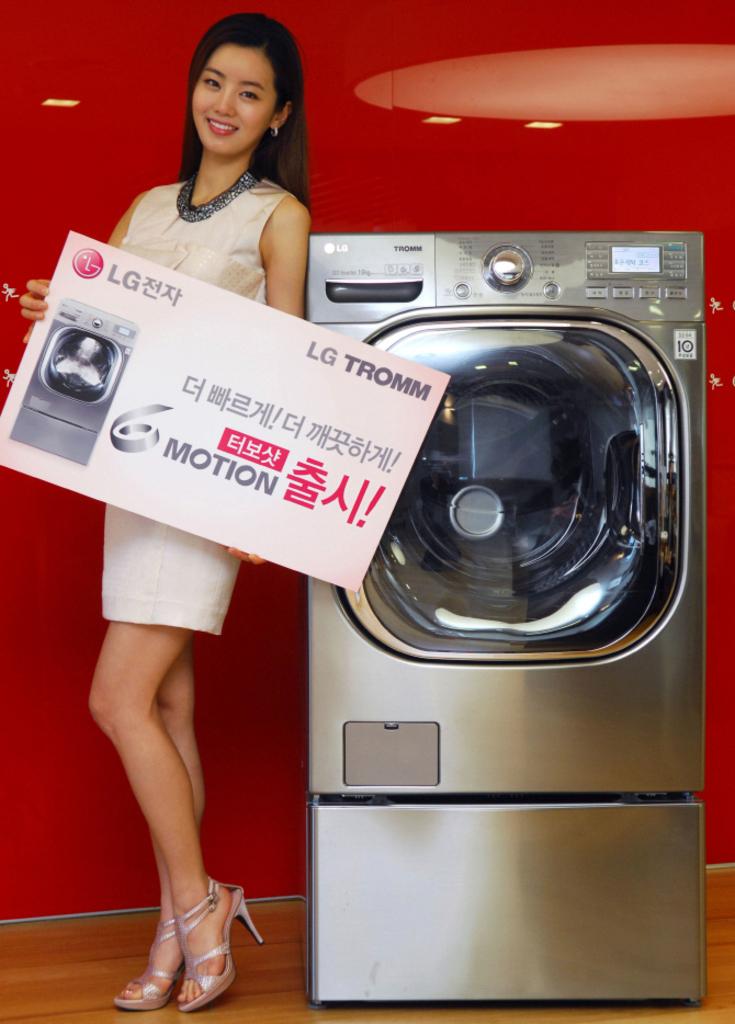What brand of washer machine is that?
Keep it short and to the point. Lg. 